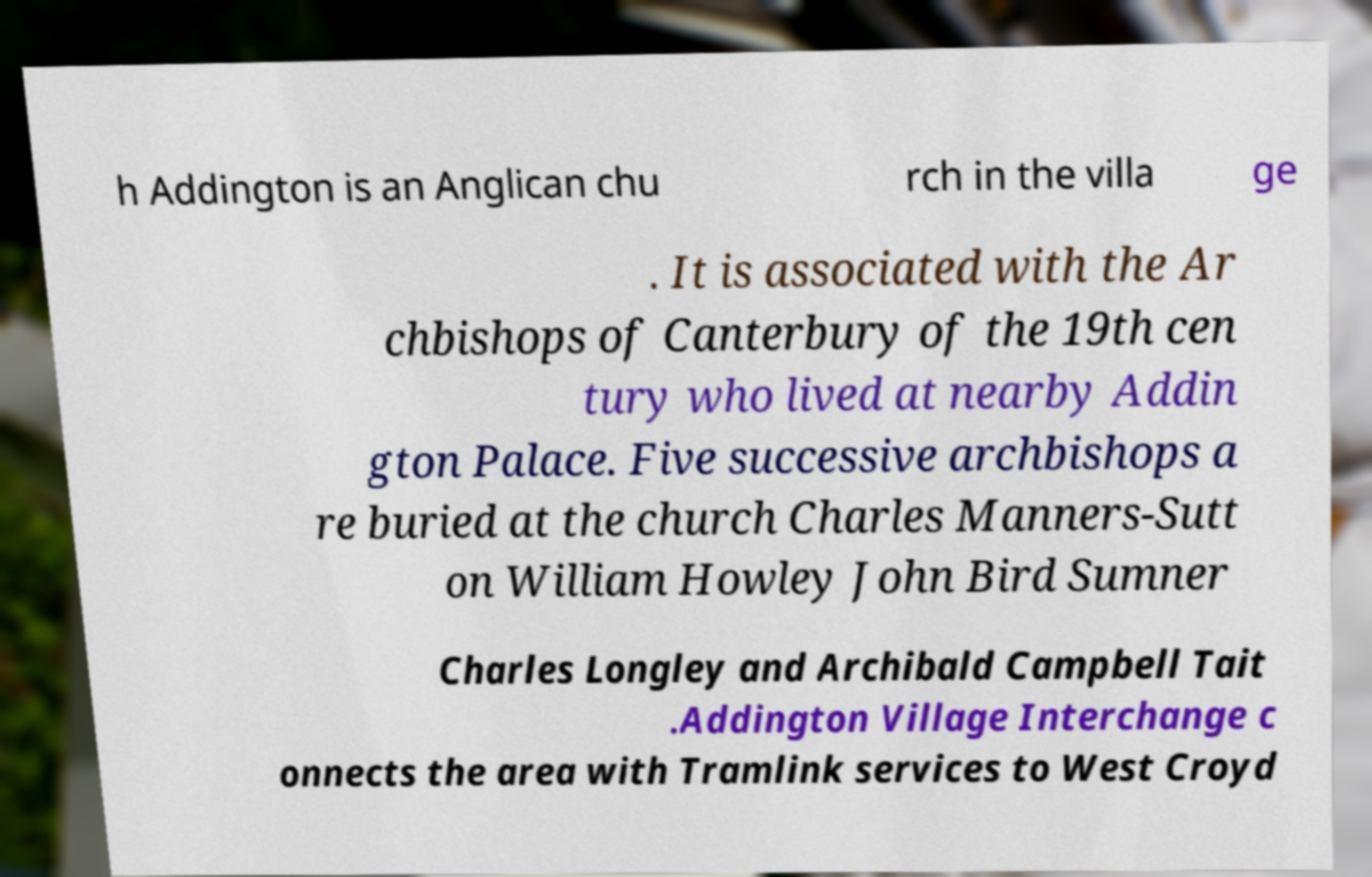Could you assist in decoding the text presented in this image and type it out clearly? h Addington is an Anglican chu rch in the villa ge . It is associated with the Ar chbishops of Canterbury of the 19th cen tury who lived at nearby Addin gton Palace. Five successive archbishops a re buried at the church Charles Manners-Sutt on William Howley John Bird Sumner Charles Longley and Archibald Campbell Tait .Addington Village Interchange c onnects the area with Tramlink services to West Croyd 